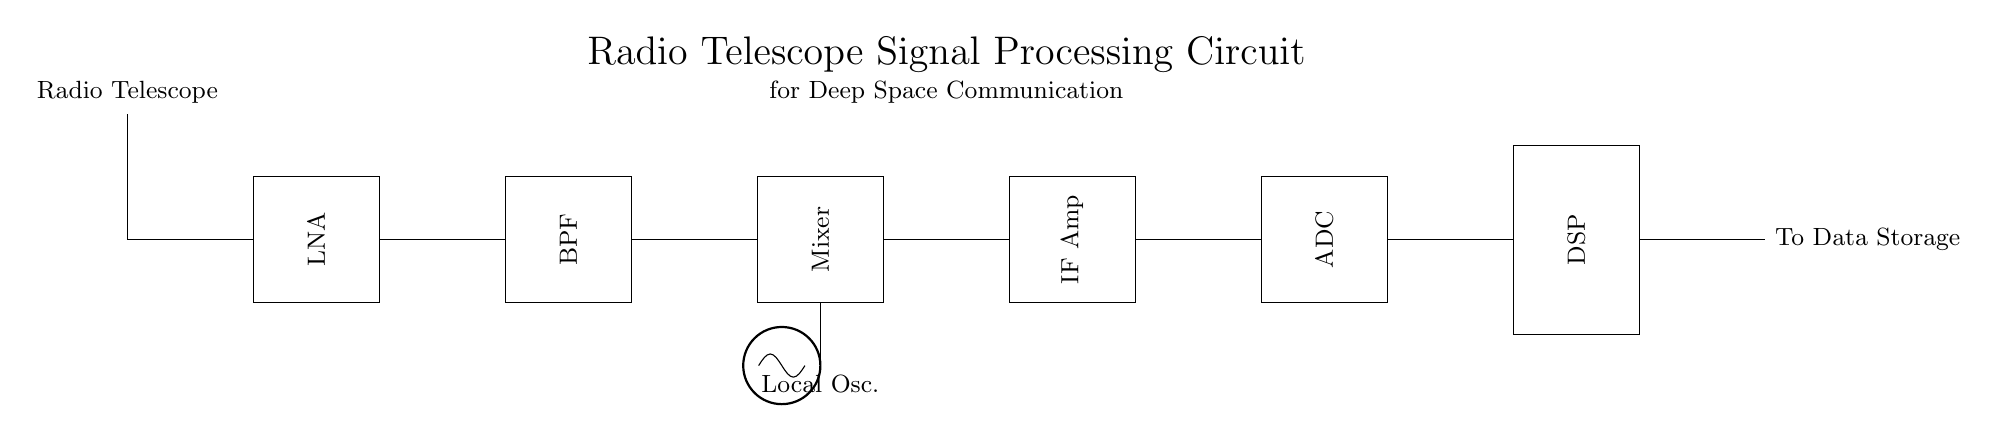What is the first component in the circuit? The first component in the circuit is the antenna, signifying the starting point of the signal processing chain.
Answer: Antenna What does LNA stand for? LNA stands for Low Noise Amplifier, which is designed to amplify weak signals received from the antenna while adding minimal noise.
Answer: Low Noise Amplifier What type of filter is used in this circuit? The circuit employs a Bandpass Filter to allow only the desired frequency range to pass while attenuating frequencies outside this range.
Answer: Bandpass Filter How many stages are there in the signal processing circuit? There are six stages in the circuit: antenna, LNA, Bandpass Filter, Mixer, IF Amplifier, and ADC. Counting the DSP as the final stage, this totals to seven components.
Answer: Seven What purpose does the DSP serve in this circuit? The Digital Signal Processor (DSP) processes the signal further after conversion to digital format by the ADC, allowing for advanced signal processing and analysis for data extraction.
Answer: Processing What component comes after the Mixer? The component that comes after the Mixer is the IF Amplifier, which further amplifies the intermediate frequency signal generated by the Mixer.
Answer: IF Amplifier Why is a Local Oscillator included in this circuit? The Local Oscillator provides a stable frequency reference that mixes with the incoming signal in the Mixer, allowing the extraction of the desired intermediate frequency from the received signal.
Answer: Frequency reference 